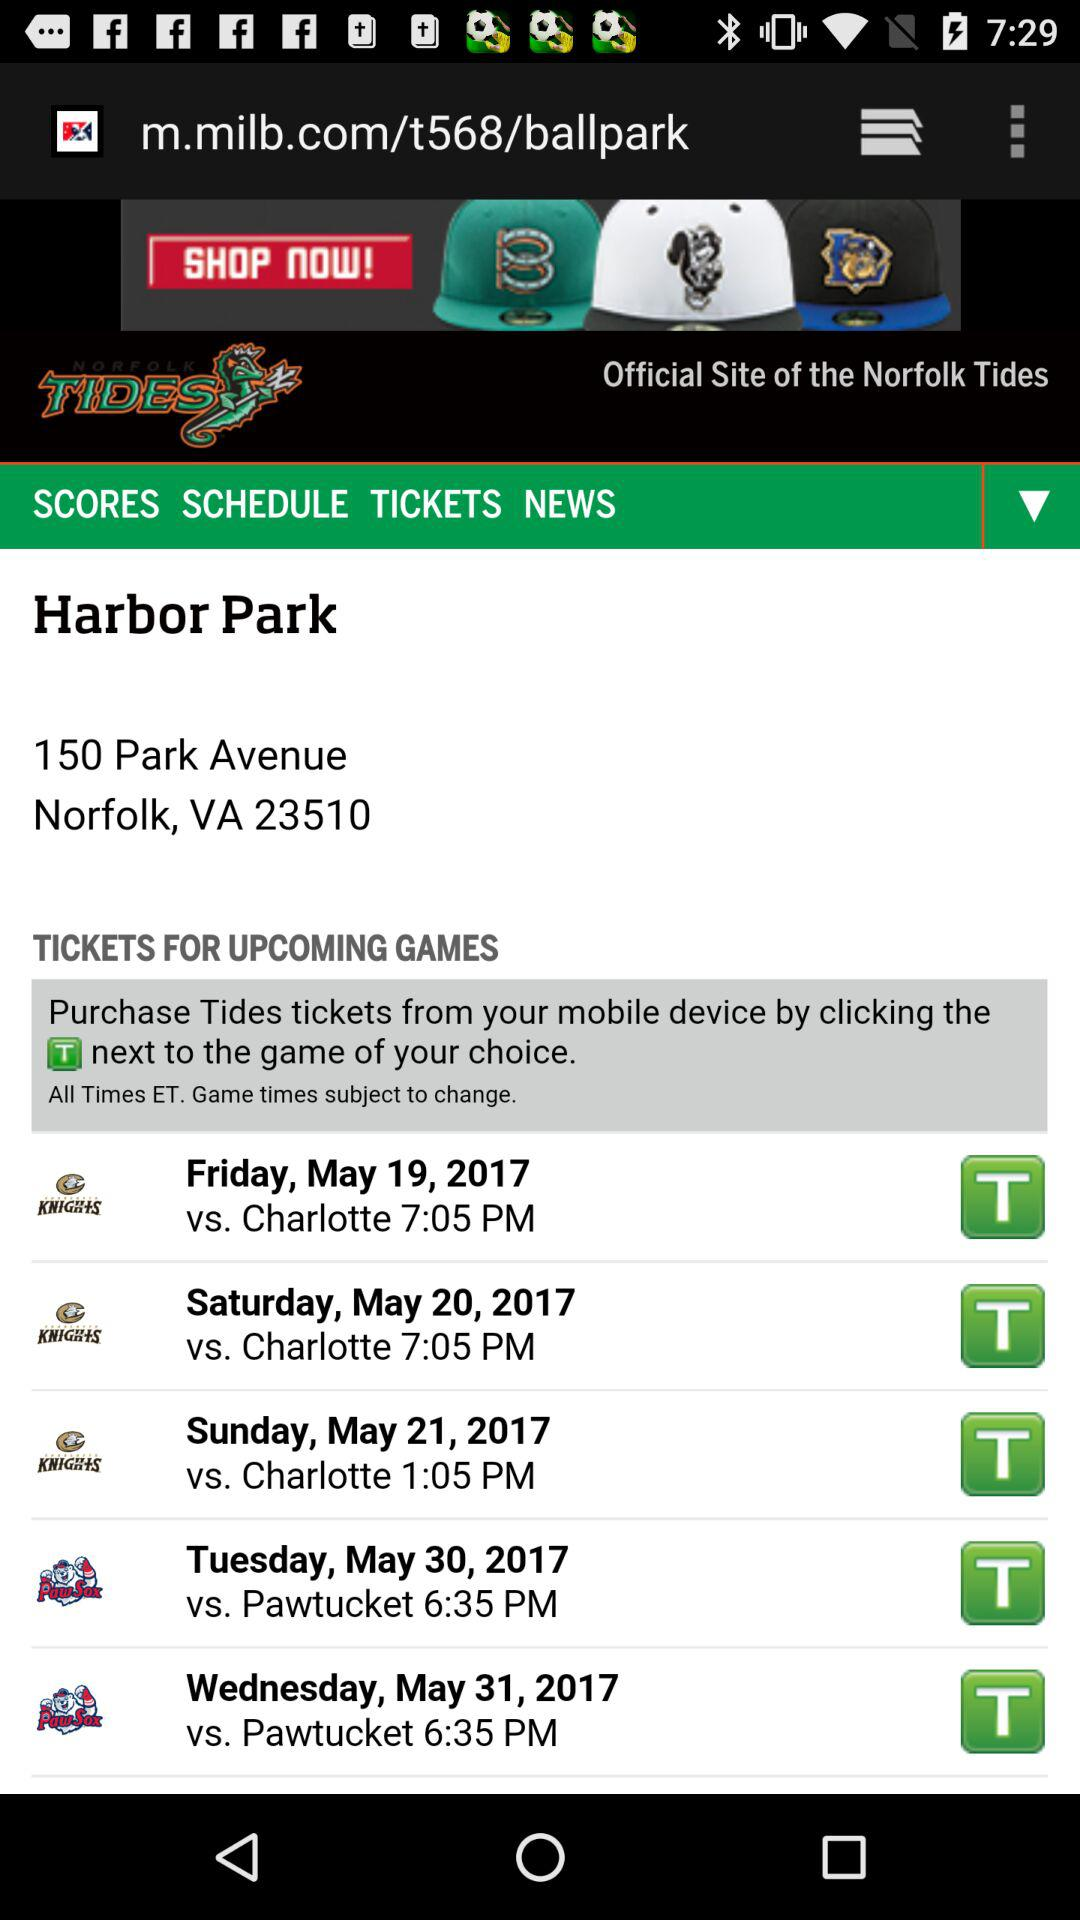Where will the match take place? The match will take place at Harbor Park, 150 Park Avenue, Norfolk, VA 23510. 